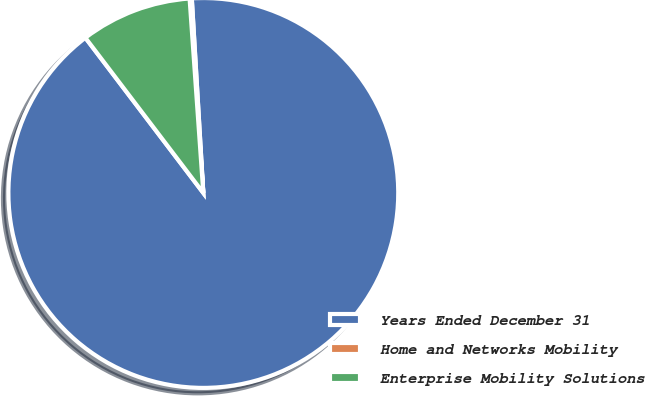Convert chart to OTSL. <chart><loc_0><loc_0><loc_500><loc_500><pie_chart><fcel>Years Ended December 31<fcel>Home and Networks Mobility<fcel>Enterprise Mobility Solutions<nl><fcel>90.6%<fcel>0.18%<fcel>9.22%<nl></chart> 